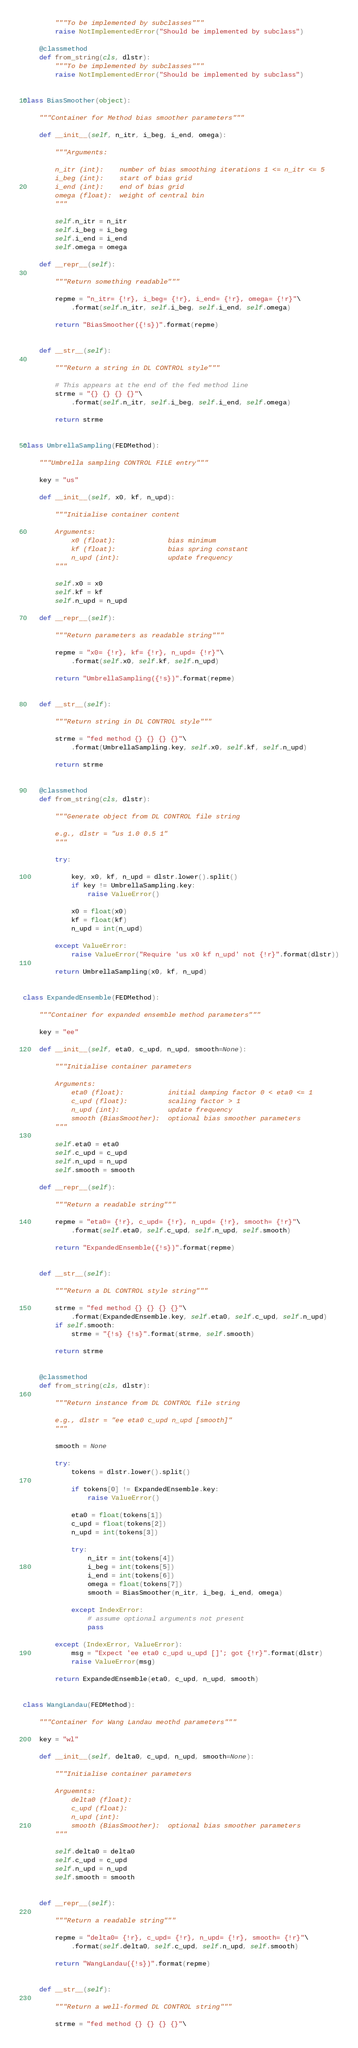<code> <loc_0><loc_0><loc_500><loc_500><_Python_>        """To be implemented by subclasses"""
        raise NotImplementedError("Should be implemented by subclass")

    @classmethod
    def from_string(cls, dlstr):
        """To be implemented by subclasses"""
        raise NotImplementedError("Should be implemented by subclass")


class BiasSmoother(object):

    """Container for Method bias smoother parameters"""

    def __init__(self, n_itr, i_beg, i_end, omega):

        """Arguments:

        n_itr (int):    number of bias smoothing iterations 1 <= n_itr <= 5
        i_beg (int):    start of bias grid
        i_end (int):    end of bias grid
        omega (float):  weight of central bin
        """

        self.n_itr = n_itr
        self.i_beg = i_beg
        self.i_end = i_end
        self.omega = omega

    def __repr__(self):

        """Return something readable"""

        repme = "n_itr= {!r}, i_beg= {!r}, i_end= {!r}, omega= {!r}"\
            .format(self.n_itr, self.i_beg, self.i_end, self.omega)

        return "BiasSmoother({!s})".format(repme)


    def __str__(self):

        """Return a string in DL CONTROL style"""

        # This appears at the end of the fed method line
        strme = "{} {} {} {}"\
            .format(self.n_itr, self.i_beg, self.i_end, self.omega)

        return strme


class UmbrellaSampling(FEDMethod):

    """Umbrella sampling CONTROL FILE entry"""

    key = "us"

    def __init__(self, x0, kf, n_upd):

        """Initialise container content

        Arguments:
            x0 (float):             bias minimum
            kf (float):             bias spring constant
            n_upd (int):            update frequency
        """

        self.x0 = x0
        self.kf = kf
        self.n_upd = n_upd

    def __repr__(self):

        """Return parameters as readable string"""

        repme = "x0= {!r}, kf= {!r}, n_upd= {!r}"\
            .format(self.x0, self.kf, self.n_upd)

        return "UmbrellaSampling({!s})".format(repme)


    def __str__(self):

        """Return string in DL CONTROL style"""

        strme = "fed method {} {} {} {}"\
            .format(UmbrellaSampling.key, self.x0, self.kf, self.n_upd)

        return strme


    @classmethod
    def from_string(cls, dlstr):

        """Generate object from DL CONTROL file string

        e.g., dlstr = "us 1.0 0.5 1"
        """

        try:

            key, x0, kf, n_upd = dlstr.lower().split()
            if key != UmbrellaSampling.key:
                raise ValueError()

            x0 = float(x0)
            kf = float(kf)
            n_upd = int(n_upd)

        except ValueError:
            raise ValueError("Require 'us x0 kf n_upd' not {!r}".format(dlstr))

        return UmbrellaSampling(x0, kf, n_upd)


class ExpandedEnsemble(FEDMethod):

    """Container for expanded ensemble method parameters"""

    key = "ee"

    def __init__(self, eta0, c_upd, n_upd, smooth=None):

        """Initialise container parameters

        Arguments:
            eta0 (float):           initial damping factor 0 < eta0 <= 1
            c_upd (float):          scaling factor > 1
            n_upd (int):            update frequency
            smooth (BiasSmoother):  optional bias smoother parameters
        """

        self.eta0 = eta0
        self.c_upd = c_upd
        self.n_upd = n_upd
        self.smooth = smooth

    def __repr__(self):

        """Return a readable string"""

        repme = "eta0= {!r}, c_upd= {!r}, n_upd= {!r}, smooth= {!r}"\
            .format(self.eta0, self.c_upd, self.n_upd, self.smooth)

        return "ExpandedEnsemble({!s})".format(repme)


    def __str__(self):

        """Return a DL CONTROL style string"""

        strme = "fed method {} {} {} {}"\
            .format(ExpandedEnsemble.key, self.eta0, self.c_upd, self.n_upd)
        if self.smooth:
            strme = "{!s} {!s}".format(strme, self.smooth)

        return strme


    @classmethod
    def from_string(cls, dlstr):

        """Return instance from DL CONTROL file string

        e.g., dlstr = "ee eta0 c_upd n_upd [smooth]"
        """

        smooth = None

        try:
            tokens = dlstr.lower().split()

            if tokens[0] != ExpandedEnsemble.key:
                raise ValueError()

            eta0 = float(tokens[1])
            c_upd = float(tokens[2])
            n_upd = int(tokens[3])

            try:
                n_itr = int(tokens[4])
                i_beg = int(tokens[5])
                i_end = int(tokens[6])
                omega = float(tokens[7])
                smooth = BiasSmoother(n_itr, i_beg, i_end, omega)

            except IndexError:
                # assume optional arguments not present
                pass

        except (IndexError, ValueError):
            msg = "Expect 'ee eta0 c_upd u_upd []'; got {!r}".format(dlstr)
            raise ValueError(msg)

        return ExpandedEnsemble(eta0, c_upd, n_upd, smooth)


class WangLandau(FEDMethod):

    """Container for Wang Landau meothd parameters"""

    key = "wl"

    def __init__(self, delta0, c_upd, n_upd, smooth=None):

        """Initialise container parameters

        Arguemnts:
            delta0 (float):
            c_upd (float):
            n_upd (int):
            smooth (BiasSmoother):  optional bias smoother parameters
        """

        self.delta0 = delta0
        self.c_upd = c_upd
        self.n_upd = n_upd
        self.smooth = smooth


    def __repr__(self):

        """Return a readable string"""

        repme = "delta0= {!r}, c_upd= {!r}, n_upd= {!r}, smooth= {!r}"\
            .format(self.delta0, self.c_upd, self.n_upd, self.smooth)

        return "WangLandau({!s})".format(repme)


    def __str__(self):

        """Return a well-formed DL CONTROL string"""

        strme = "fed method {} {} {} {}"\</code> 